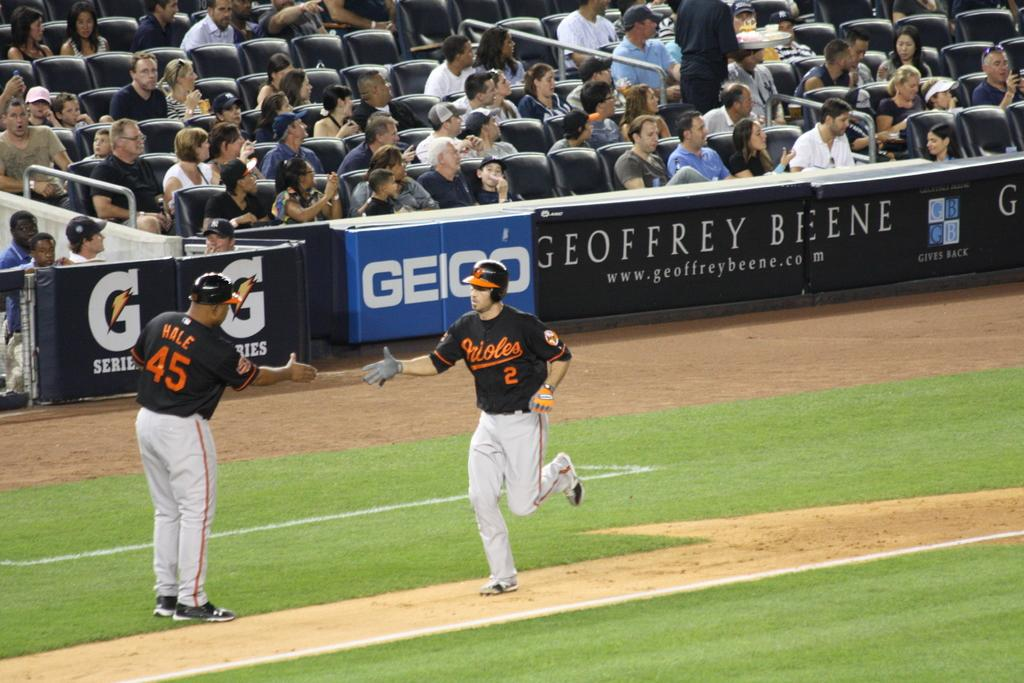Provide a one-sentence caption for the provided image. An Orioles player shakes another player's hand as he rounds the bases. 